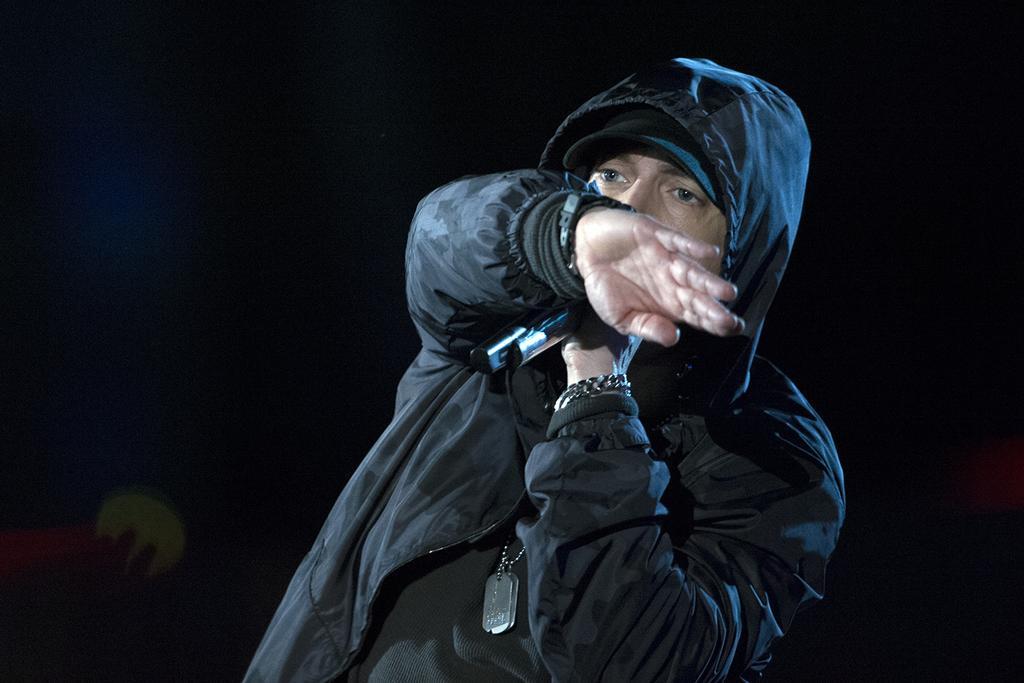In one or two sentences, can you explain what this image depicts? In the image in the center we can see one person standing and holding microphone and he is wearing black color jacket. 